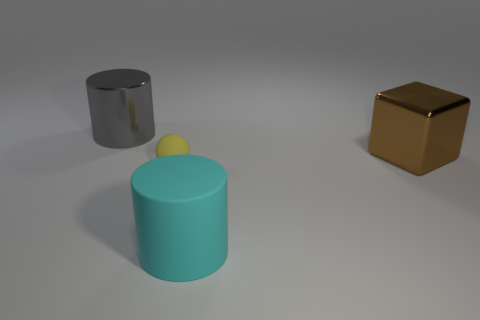What is the color of the other thing that is the same material as the large cyan thing?
Provide a short and direct response. Yellow. There is a shiny thing left of the brown object; is its size the same as the large cyan cylinder?
Keep it short and to the point. Yes. There is a large shiny thing that is the same shape as the large cyan matte object; what color is it?
Offer a very short reply. Gray. What is the shape of the big thing that is to the left of the cyan rubber cylinder right of the cylinder behind the tiny yellow matte thing?
Provide a succinct answer. Cylinder. Is the tiny matte thing the same shape as the big brown thing?
Your response must be concise. No. There is a metallic object left of the metallic block that is right of the small yellow matte sphere; what is its shape?
Your answer should be compact. Cylinder. Is there a yellow rubber thing?
Your answer should be very brief. Yes. What number of large cylinders are left of the matte thing to the left of the rubber thing that is to the right of the small matte object?
Offer a very short reply. 1. There is a yellow thing; is its shape the same as the matte object that is on the right side of the yellow ball?
Provide a succinct answer. No. Are there more large yellow metal blocks than tiny yellow objects?
Your answer should be very brief. No. 